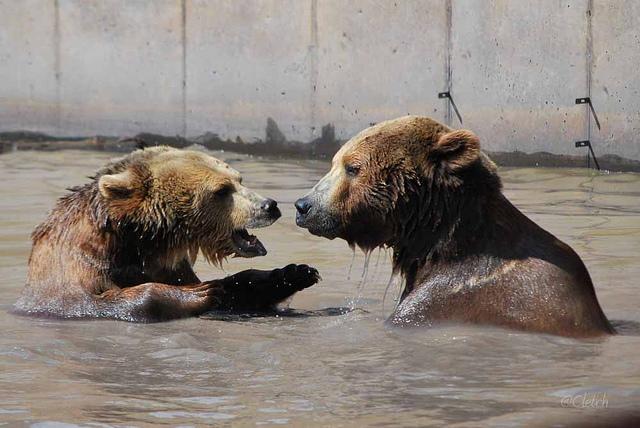Are these bears in a zoo?
Concise answer only. Yes. Are the bears fighting?
Give a very brief answer. Yes. How many bears have exposed paws?
Short answer required. 1. 